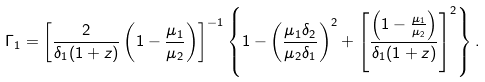<formula> <loc_0><loc_0><loc_500><loc_500>\Gamma _ { 1 } = \left [ \frac { 2 } { \delta _ { 1 } ( 1 + z ) } \left ( 1 - \frac { \mu _ { 1 } } { \mu _ { 2 } } \right ) \right ] ^ { - 1 } \left \{ 1 - \left ( \frac { \mu _ { 1 } \delta _ { 2 } } { \mu _ { 2 } \delta _ { 1 } } \right ) ^ { 2 } + \left [ \frac { \left ( 1 - \frac { \mu _ { 1 } } { \mu _ { 2 } } \right ) } { \delta _ { 1 } ( 1 + z ) } \right ] ^ { 2 } \right \} .</formula> 